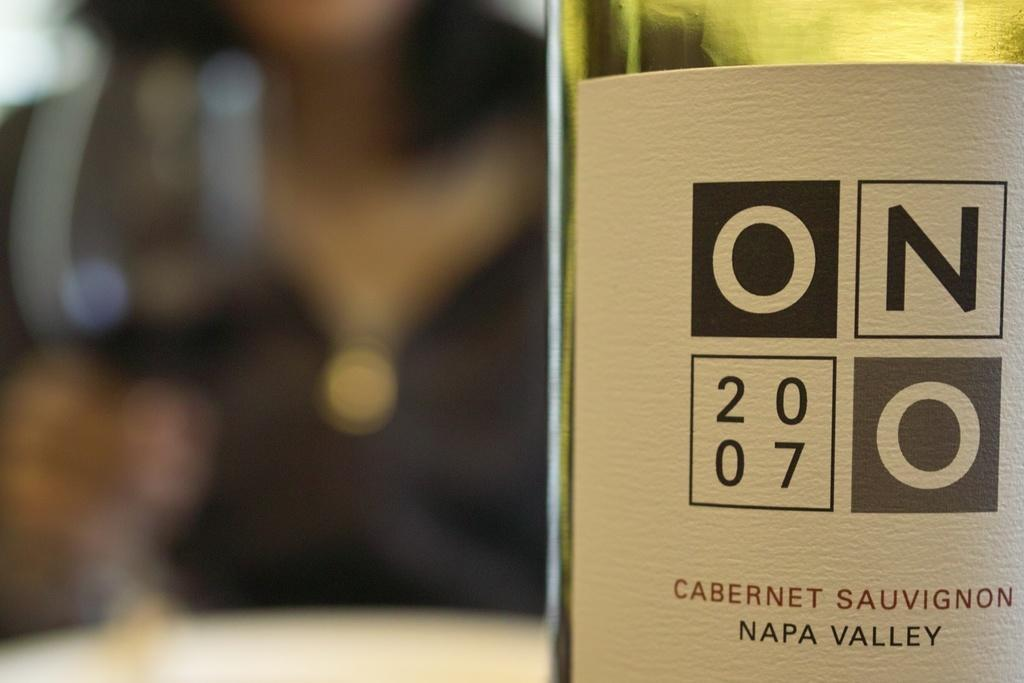What is on the table in the image? There is a wine bottle on the table. What can be read on the label of the wine bottle? The wine bottle is labeled "Napa Valley". Can you describe the person visible in the background of the image? Unfortunately, the provided facts do not give any information about the person in the background. What type of jewel is the boy wearing in the image? There is no boy or jewel present in the image. 